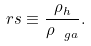Convert formula to latex. <formula><loc_0><loc_0><loc_500><loc_500>\ r s \equiv \frac { \rho _ { h } } { \rho _ { \ g a } } .</formula> 